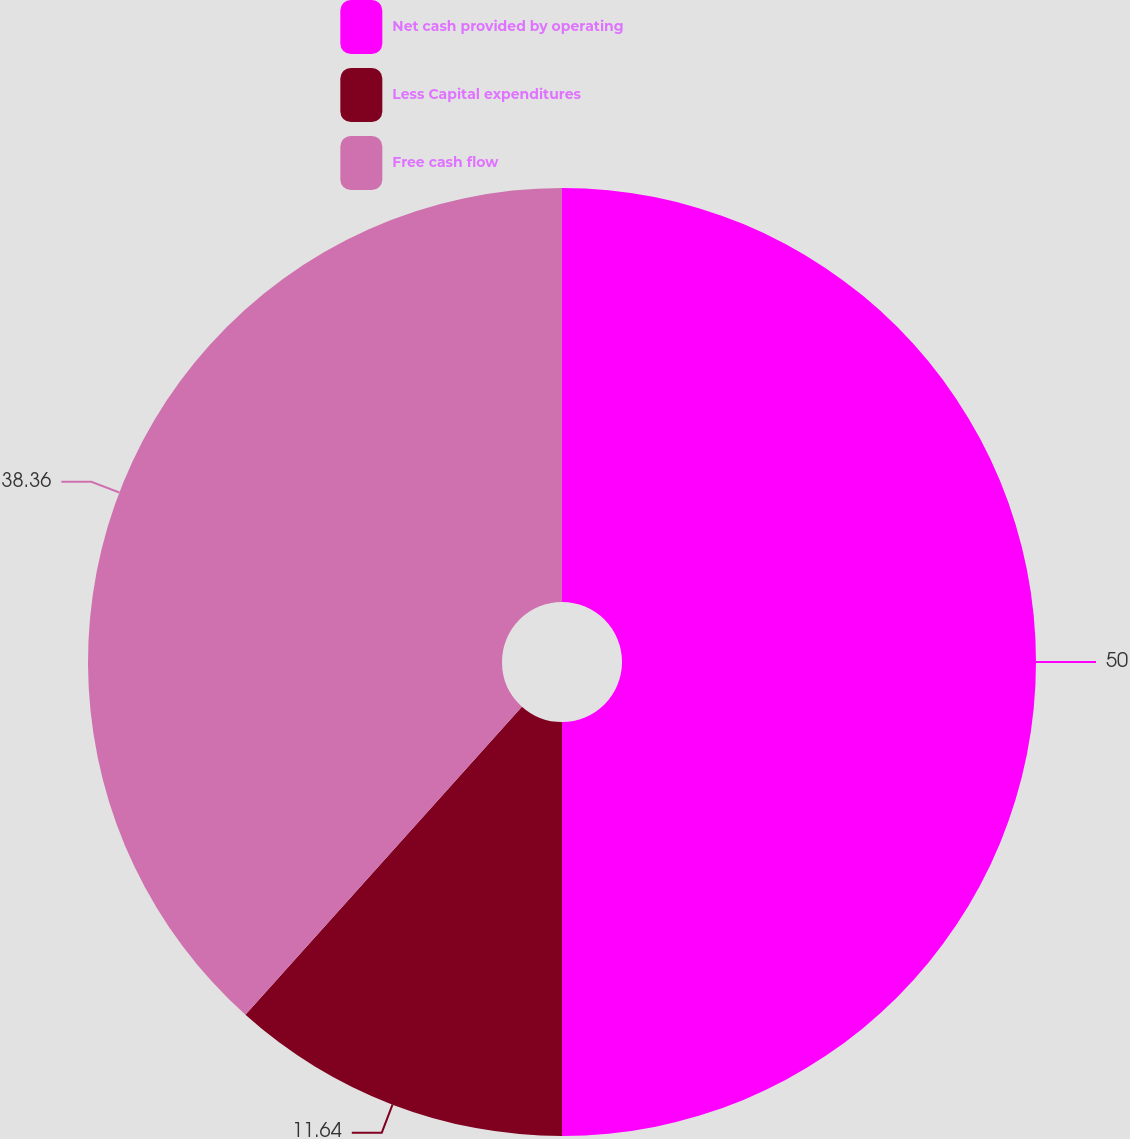Convert chart. <chart><loc_0><loc_0><loc_500><loc_500><pie_chart><fcel>Net cash provided by operating<fcel>Less Capital expenditures<fcel>Free cash flow<nl><fcel>50.0%<fcel>11.64%<fcel>38.36%<nl></chart> 